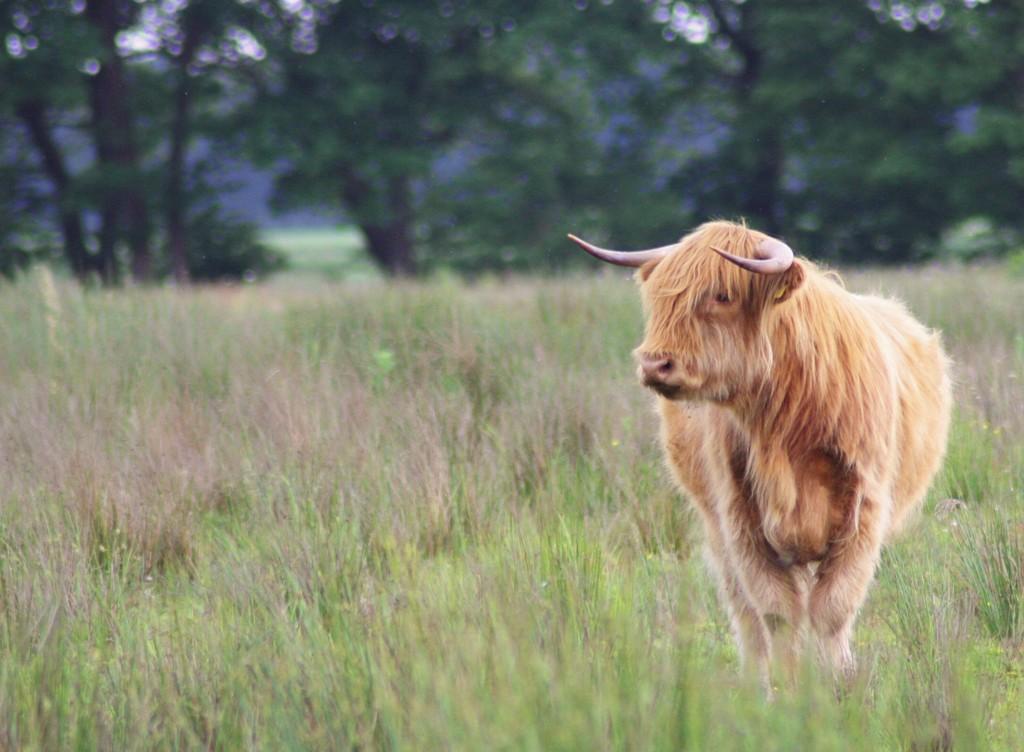Can you describe this image briefly? In this image an animal is standing at the right side of image. Background there are few trees on the grassland. 